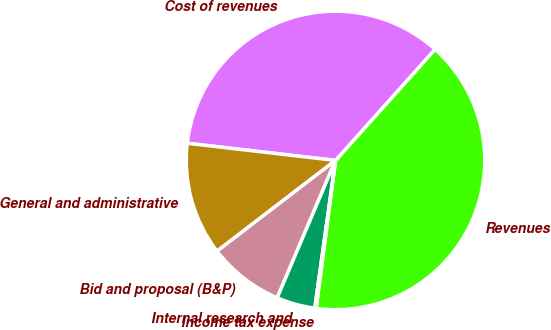Convert chart to OTSL. <chart><loc_0><loc_0><loc_500><loc_500><pie_chart><fcel>Revenues<fcel>Cost of revenues<fcel>General and administrative<fcel>Bid and proposal (B&P)<fcel>Internal research and<fcel>Income tax expense<nl><fcel>40.45%<fcel>34.79%<fcel>12.24%<fcel>8.21%<fcel>4.17%<fcel>0.14%<nl></chart> 